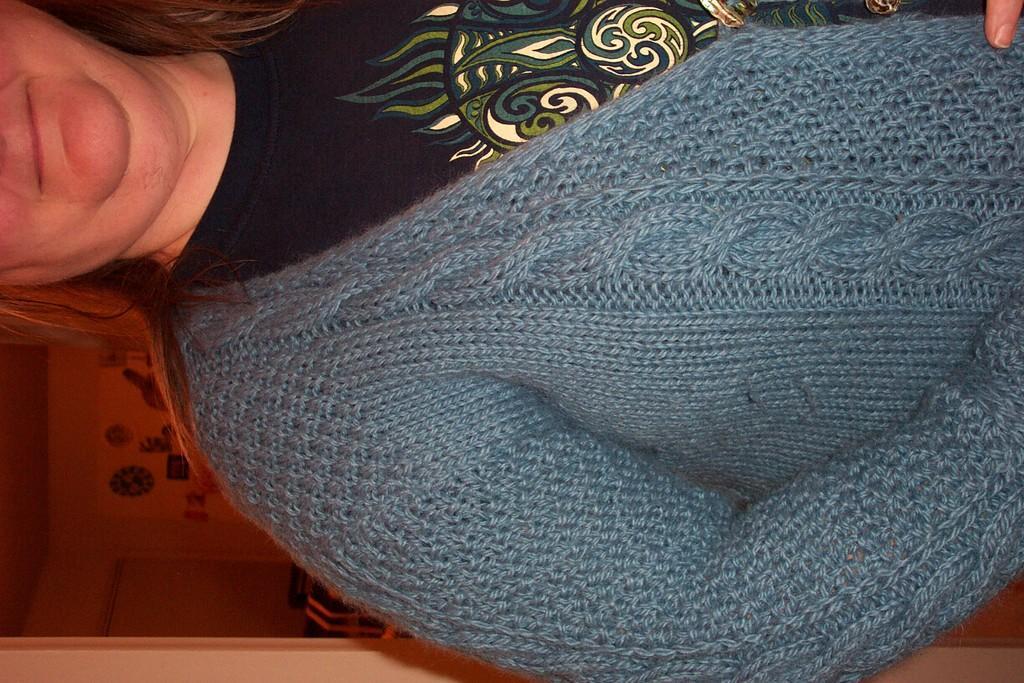Could you give a brief overview of what you see in this image? It is an inverted image,there is a woman and she is wearing a blue sweater and only half part of the woman is visible and behind the woman there is a room. 